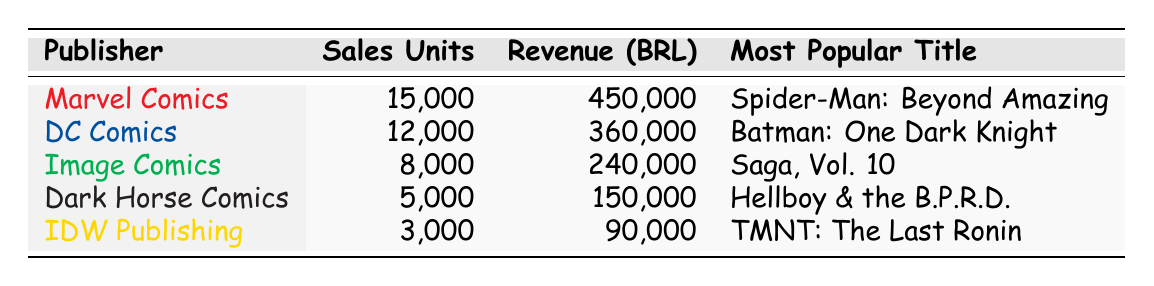What is the total revenue generated by Marvel Comics? According to the table, Marvel Comics has a revenue of 450,000 BRL. There is no need for any calculations since the figure is directly provided in the table.
Answer: 450,000 BRL Which publisher had the lowest sales units in São Paulo in 2023? Looking at the Sales Units column, IDW Publishing has the lowest sales units at 3,000. This can be confirmed by comparing all the sales units listed for each publisher.
Answer: IDW Publishing What is the average number of sales units for all publishers? To find the average, add the sales units of all publishers: 15,000 + 12,000 + 8,000 + 5,000 + 3,000 = 43,000. Then divide by the number of publishers (5): 43,000 / 5 = 8,600.
Answer: 8,600 Is the revenue from Image Comics higher than that of Dark Horse Comics? Image Comics generated 240,000 BRL, while Dark Horse Comics generated 150,000 BRL. Since 240,000 is greater than 150,000, the statement is true.
Answer: Yes Which publisher had more sales units: DC Comics or Dark Horse Comics? DC Comics had 12,000 sales units while Dark Horse Comics had 5,000. By comparing these two figures, it's clear that DC Comics had significantly more sales units.
Answer: DC Comics What is the combined revenue from Marvel Comics and DC Comics? To find the combined revenue, sum the revenue figures for both publishers: 450,000 (Marvel) + 360,000 (DC) = 810,000 BRL. This requires looking at both revenue values and adding them together.
Answer: 810,000 BRL How many more sales units did Marvel Comics sell compared to IDW Publishing? Marvel Comics sold 15,000 units while IDW Publishing sold 3,000 units. The difference is 15,000 - 3,000 = 12,000 units. This calculation directly shows how many units more Marvel sold.
Answer: 12,000 units Does any publisher have a popular title that includes 'Teenage Mutant Ninja Turtles' in its name? According to the table, IDW Publishing's most popular title is "Teenage Mutant Ninja Turtles: The Last Ronin." So, the statement is true.
Answer: Yes 